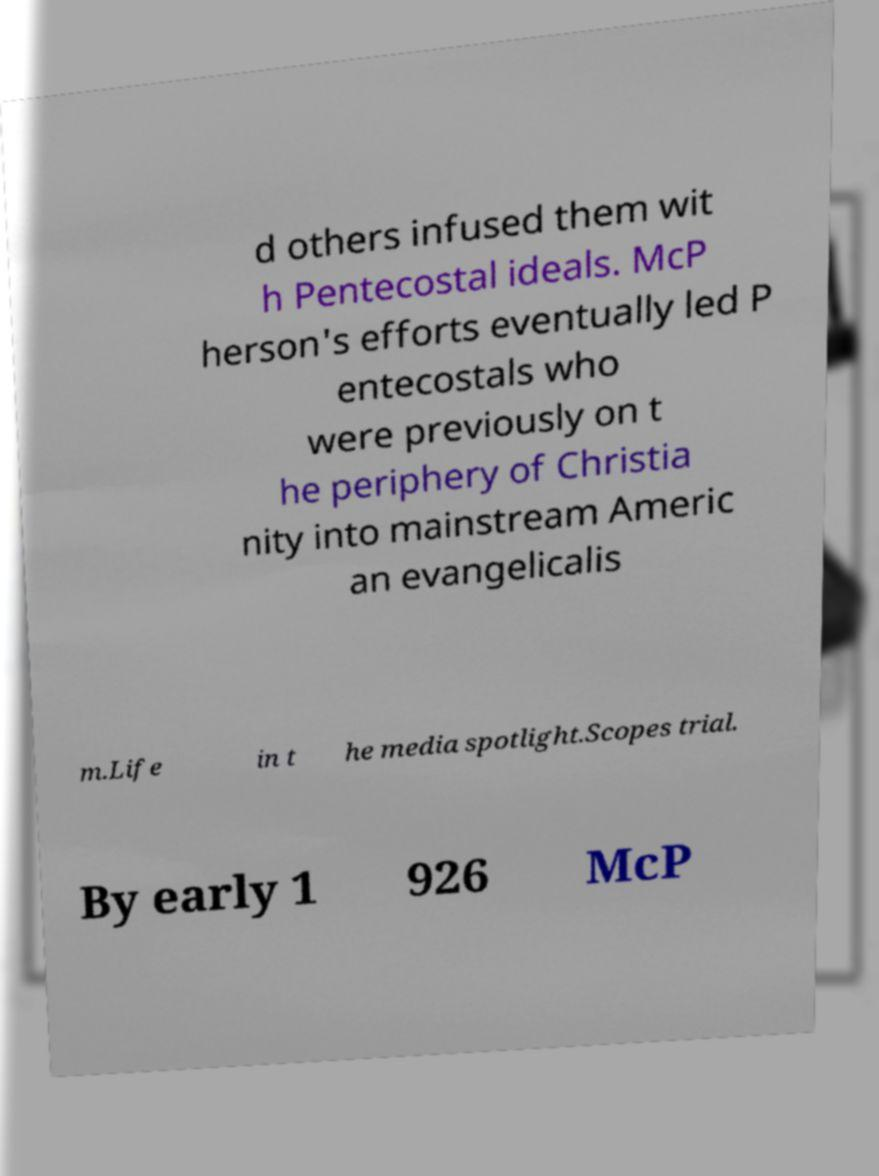Please read and relay the text visible in this image. What does it say? d others infused them wit h Pentecostal ideals. McP herson's efforts eventually led P entecostals who were previously on t he periphery of Christia nity into mainstream Americ an evangelicalis m.Life in t he media spotlight.Scopes trial. By early 1 926 McP 